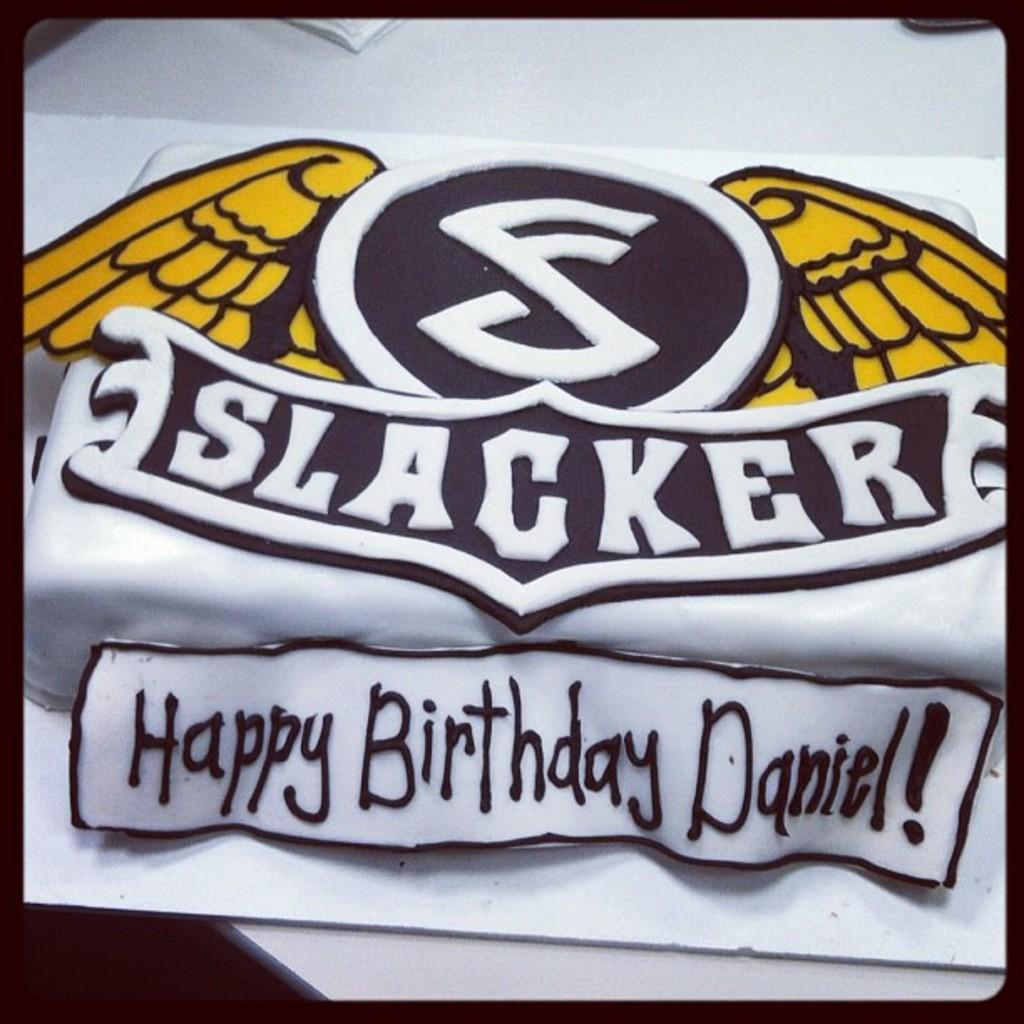What is the main feature in the center of the image? There is a logo in the center of the image. Where can you find text in the image? The text is located at the bottom side of the image. What historical event is depicted in the image? A: There is no historical event depicted in the image; it features a logo and text. How much powder is visible in the image? There is no powder present in the image. 